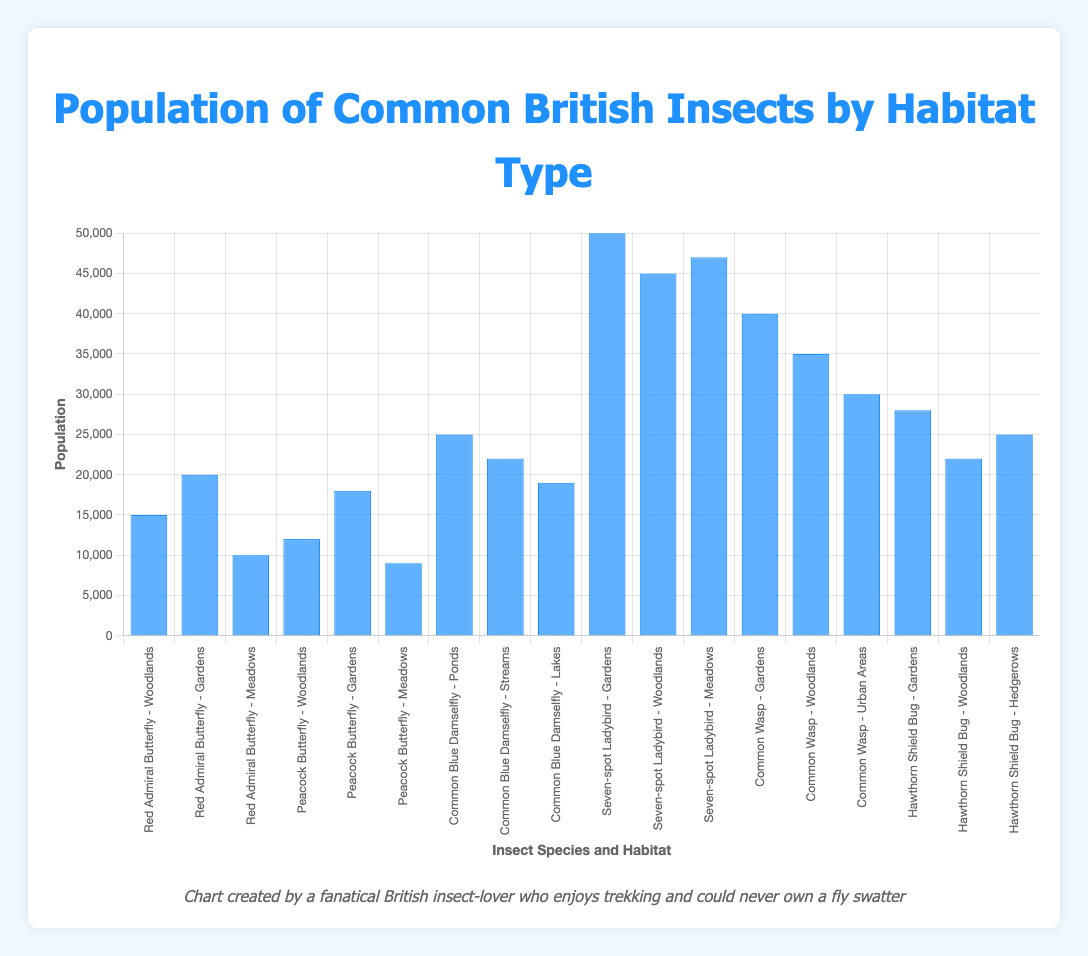Which insect has the largest population in gardens? To find the largest population in gardens, check the population values for insects in the "Gardens" habitat. The Seven-spot Ladybird has 50,000, which is the highest.
Answer: Seven-spot Ladybird What is the combined population of the Common Blue Damselfly in all its habitats? The Common Blue Damselfly appears in Ponds, Streams, and Lakes with populations of 25,000, 22,000, and 19,000 respectively. Summing these values gives 25,000 + 22,000 + 19,000 = 66,000.
Answer: 66,000 Which habitat has the highest average population of insects? Calculate the average population for each habitat:
- Woodlands: (15,000 + 12,000 + 45,000 + 35,000 + 22,000)/5 = 25,800
- Gardens: (20,000 + 18,000 + 50,000 + 40,000 + 28,000)/5 = 31,200
- Meadows: (10,000 + 9,000 + 47,000)/3 = 22,000
- Ponds: 25,000/1 = 25,000
- Streams: 22,000/1 = 22,000
- Lakes: 19,000/1 = 19,000
- Urban Areas: 30,000/1 = 30,000
- Hedgerows: 25,000/1 = 25,000
Gardens have the highest average population of 31,200.
Answer: Gardens Which insect species has the lowest population in any given habitat? Compare the populations of each insect species in various habitats and find the lowest value. The Peacock Butterfly in Meadows has a population of 9,000, which is the lowest.
Answer: Peacock Butterfly Between the Seven-spot Ladybird and the Common Wasp, which one has a larger total population? Sum the populations for each habitat for both species:
- Seven-spot Ladybird: 50,000 (Gardens) + 45,000 (Woodlands) + 47,000 (Meadows) = 142,000
- Common Wasp: 40,000 (Gardens) + 35,000 (Woodlands) + 30,000 (Urban Areas) = 105,000
The Seven-spot Ladybird has a larger total population of 142,000.
Answer: Seven-spot Ladybird Which insect has the second highest population in woodlands? In Woodlands, the populations are: Red Admiral Butterfly (15,000), Peacock Butterfly (12,000), Seven-spot Ladybird (45,000), Common Wasp (35,000), and Hawthorn Shield Bug (22,000). The second highest is the Common Wasp with 35,000.
Answer: Common Wasp 